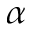Convert formula to latex. <formula><loc_0><loc_0><loc_500><loc_500>\alpha</formula> 